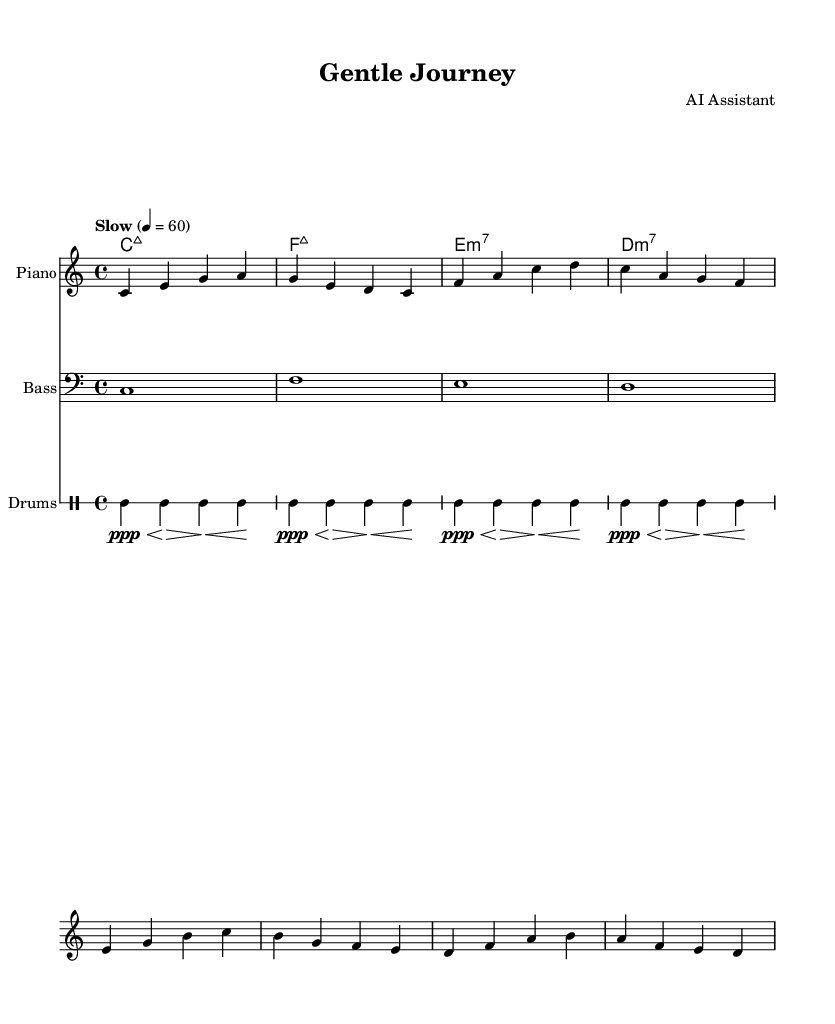What is the key signature of this music? The key signature is C major, which has no sharps or flats.
Answer: C major What is the time signature of the piece? The time signature is indicated by the numbers at the beginning of the music, showing 4 beats per measure.
Answer: 4/4 What is the tempo marking of this piece? The tempo marking is specified as "Slow" with a metronome marking of 60 beats per minute, indicating a relaxed pace.
Answer: Slow, 60 How many measures are in the melody? By counting the measures indicated by the vertical bar lines in the melody, there are a total of four measures.
Answer: Four What type of seventh chord is indicated in the harmonies? The first chord shown in the harmonies is a major seventh chord, which is a characteristic sound in jazz music.
Answer: Major 7th What instrument plays the melody? The top staff is labeled as "Piano," indicating that the piano is the primary instrument playing the melody.
Answer: Piano What is the dynamic indication for the drum part? The dynamics for the drum part indicate a very soft volume with the marking "ppp" at the beginning.
Answer: ppp 